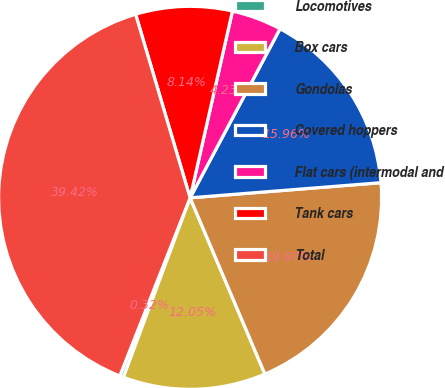Convert chart to OTSL. <chart><loc_0><loc_0><loc_500><loc_500><pie_chart><fcel>Locomotives<fcel>Box cars<fcel>Gondolas<fcel>Covered hoppers<fcel>Flat cars (intermodal and<fcel>Tank cars<fcel>Total<nl><fcel>0.32%<fcel>12.05%<fcel>19.87%<fcel>15.96%<fcel>4.23%<fcel>8.14%<fcel>39.42%<nl></chart> 